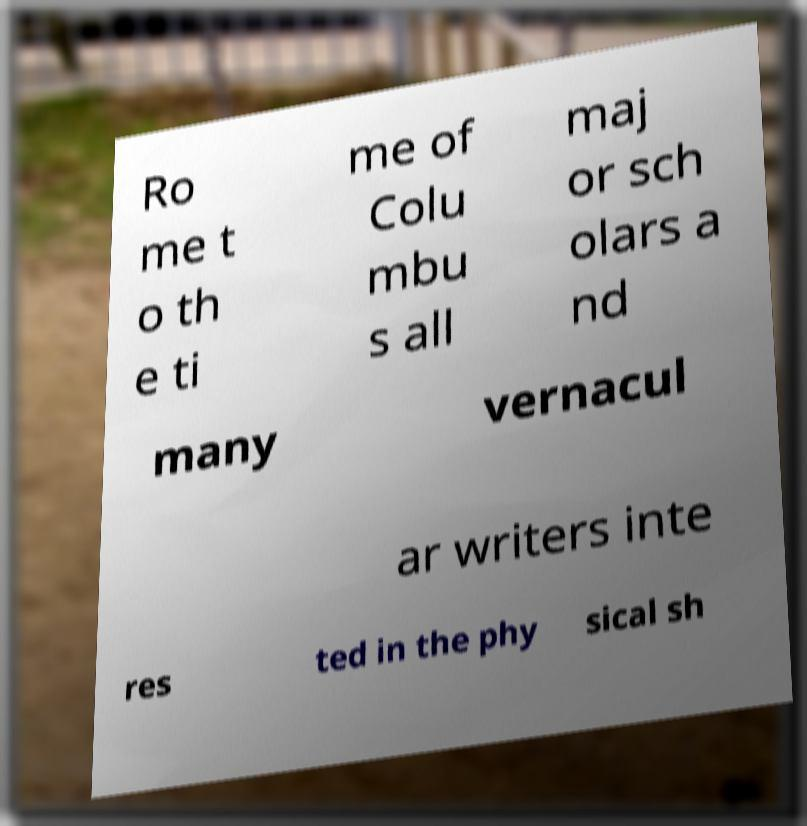Could you assist in decoding the text presented in this image and type it out clearly? Ro me t o th e ti me of Colu mbu s all maj or sch olars a nd many vernacul ar writers inte res ted in the phy sical sh 